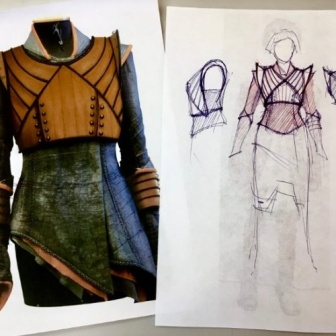Analyze the image in a comprehensive and detailed manner. The image presents an elegant garment alongside its conceptual sketch, a visual representation of the journey from idea to finished product in the realm of fashion design. The dress has a structured, high-necked bodice adorned with what appears to be brown leather detailing and rivets, evoking a warrior-like aesthetic. Its color palette is a rich combination of earthy brown and a deep forest green, lending the piece a sense of grounded opulence. The skirt part is constructed with layered fabric, creating movement and adding a tactile quality to the piece. 

The sketch, to the right of the dress, showcases the initial vision of the designer. It's detailed with annotations, indicating a thoughtful design process geared towards functionality and style. Despite being rendered in simple lines, the drawing encapsulates the essence of the garment's construction. 

Positioned side by side on a clean, white background, the garment and its sketch invite viewers to ponder the meticulous craftsmanship involved in bringing a fashion concept to life, and how the two-dimensional lines on paper blossom into a wearable form of art. No distractions in the background ensure the observer's focus remains on the craftsmanship and artistry embodied within the dress design and execution. 